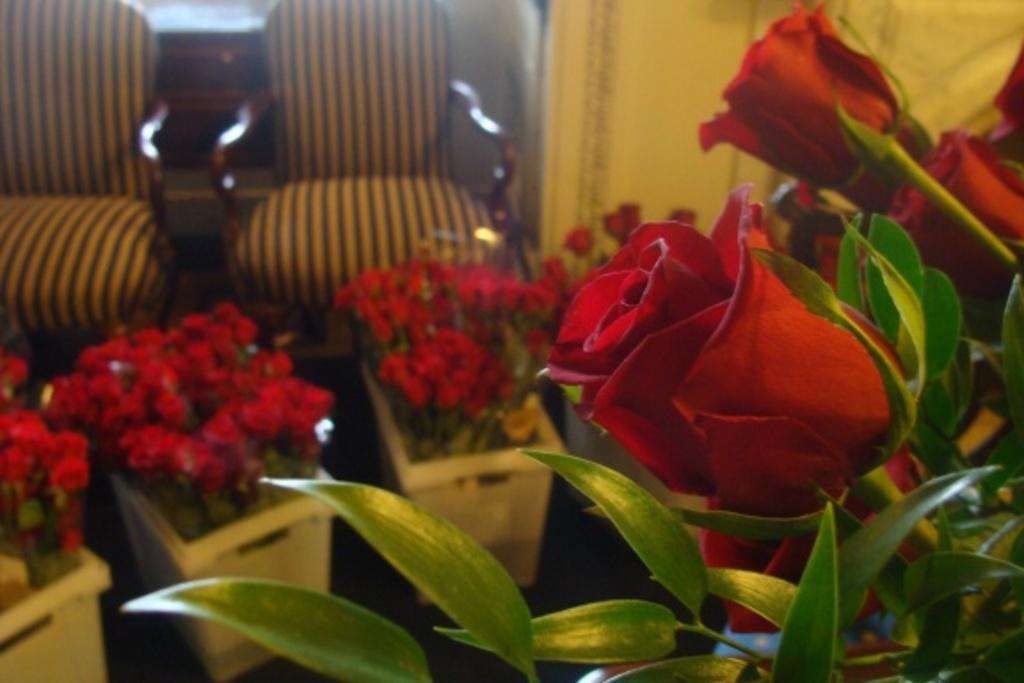What type of flowers can be seen in the image? There are roses in the image. What else is present along with the roses? There are leaves in the image. What can be seen in the background of the image? There are flower pots and chairs in the background of the image, as well as a wall. How many geese are wearing skirts in the image? There are no geese or skirts present in the image. Can you tell me the order in which the flowers were planted in the image? The order in which the flowers were planted cannot be determined from the image. 